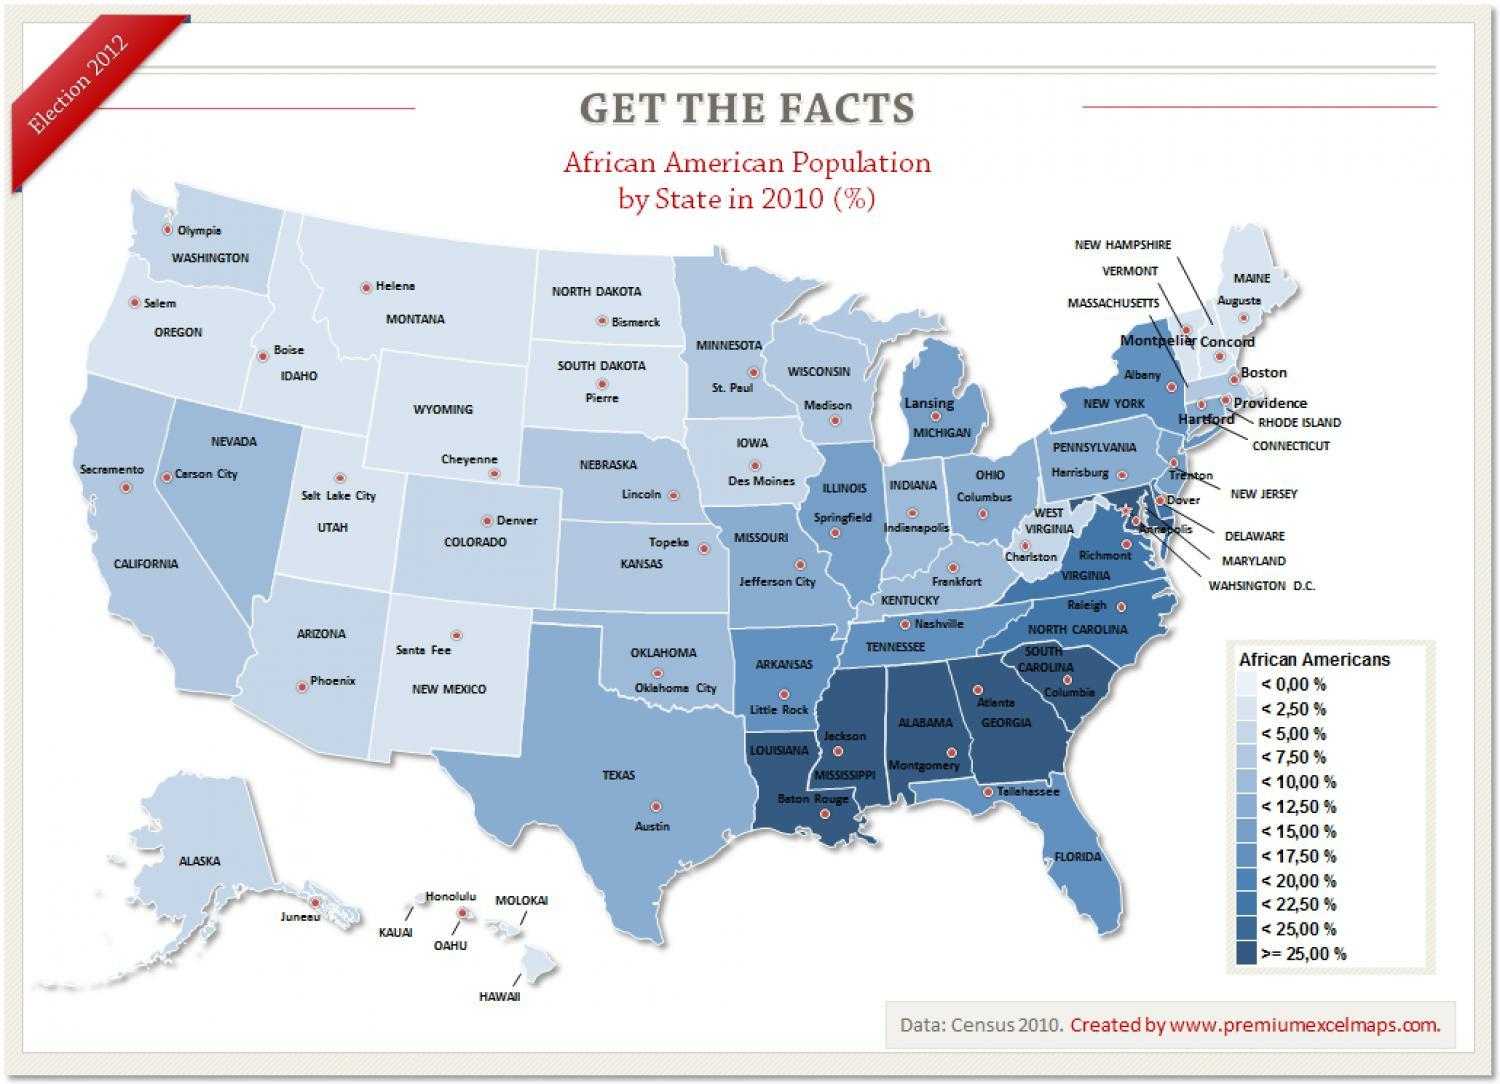How many groups of African Americans mentioned in this infographic?
Answer the question with a short phrase. 12 